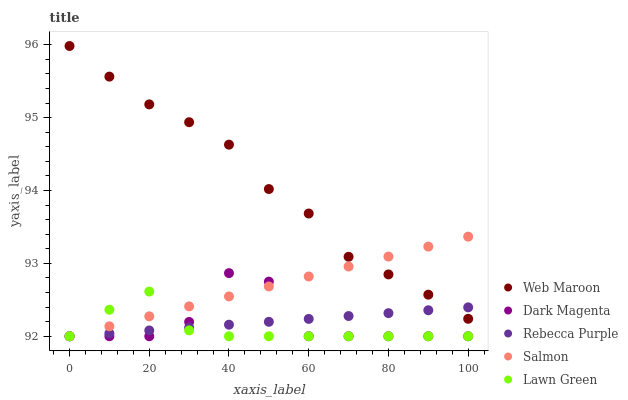Does Lawn Green have the minimum area under the curve?
Answer yes or no. Yes. Does Web Maroon have the maximum area under the curve?
Answer yes or no. Yes. Does Dark Magenta have the minimum area under the curve?
Answer yes or no. No. Does Dark Magenta have the maximum area under the curve?
Answer yes or no. No. Is Salmon the smoothest?
Answer yes or no. Yes. Is Dark Magenta the roughest?
Answer yes or no. Yes. Is Web Maroon the smoothest?
Answer yes or no. No. Is Web Maroon the roughest?
Answer yes or no. No. Does Salmon have the lowest value?
Answer yes or no. Yes. Does Web Maroon have the lowest value?
Answer yes or no. No. Does Web Maroon have the highest value?
Answer yes or no. Yes. Does Dark Magenta have the highest value?
Answer yes or no. No. Is Lawn Green less than Web Maroon?
Answer yes or no. Yes. Is Web Maroon greater than Lawn Green?
Answer yes or no. Yes. Does Dark Magenta intersect Salmon?
Answer yes or no. Yes. Is Dark Magenta less than Salmon?
Answer yes or no. No. Is Dark Magenta greater than Salmon?
Answer yes or no. No. Does Lawn Green intersect Web Maroon?
Answer yes or no. No. 